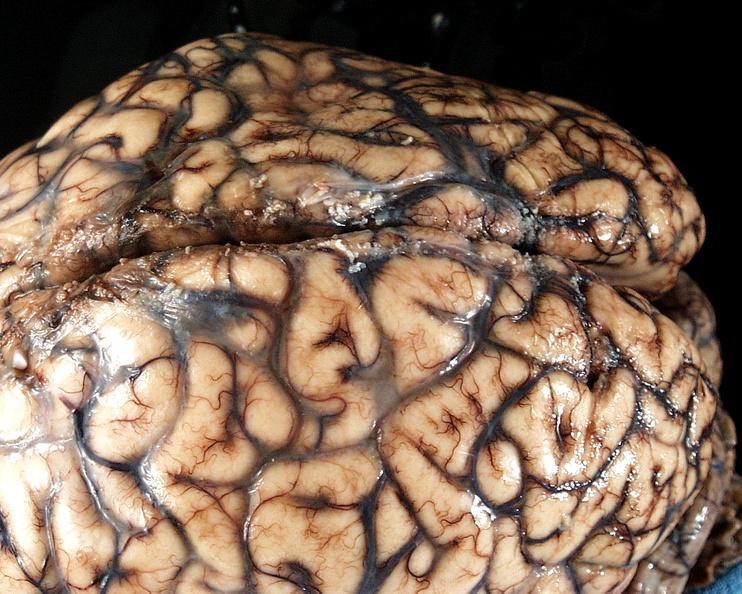s nervous present?
Answer the question using a single word or phrase. Yes 